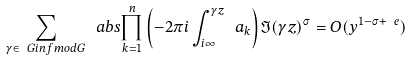<formula> <loc_0><loc_0><loc_500><loc_500>\sum _ { \gamma \in \ G i n f m o d G } \ a b s { \prod _ { k = 1 } ^ { n } \left ( - 2 \pi i \int _ { i \infty } ^ { \gamma z } \ a _ { k } \right ) } \Im ( \gamma z ) ^ { \sigma } = O ( y ^ { 1 - \sigma + \ e } )</formula> 